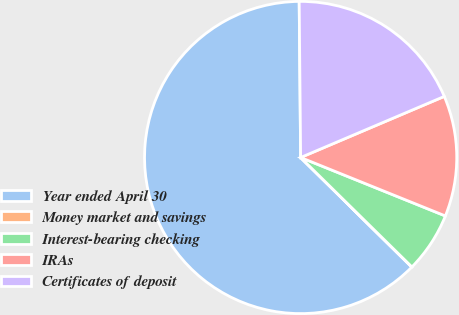<chart> <loc_0><loc_0><loc_500><loc_500><pie_chart><fcel>Year ended April 30<fcel>Money market and savings<fcel>Interest-bearing checking<fcel>IRAs<fcel>Certificates of deposit<nl><fcel>62.47%<fcel>0.02%<fcel>6.26%<fcel>12.51%<fcel>18.75%<nl></chart> 